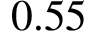<formula> <loc_0><loc_0><loc_500><loc_500>0 . 5 5</formula> 